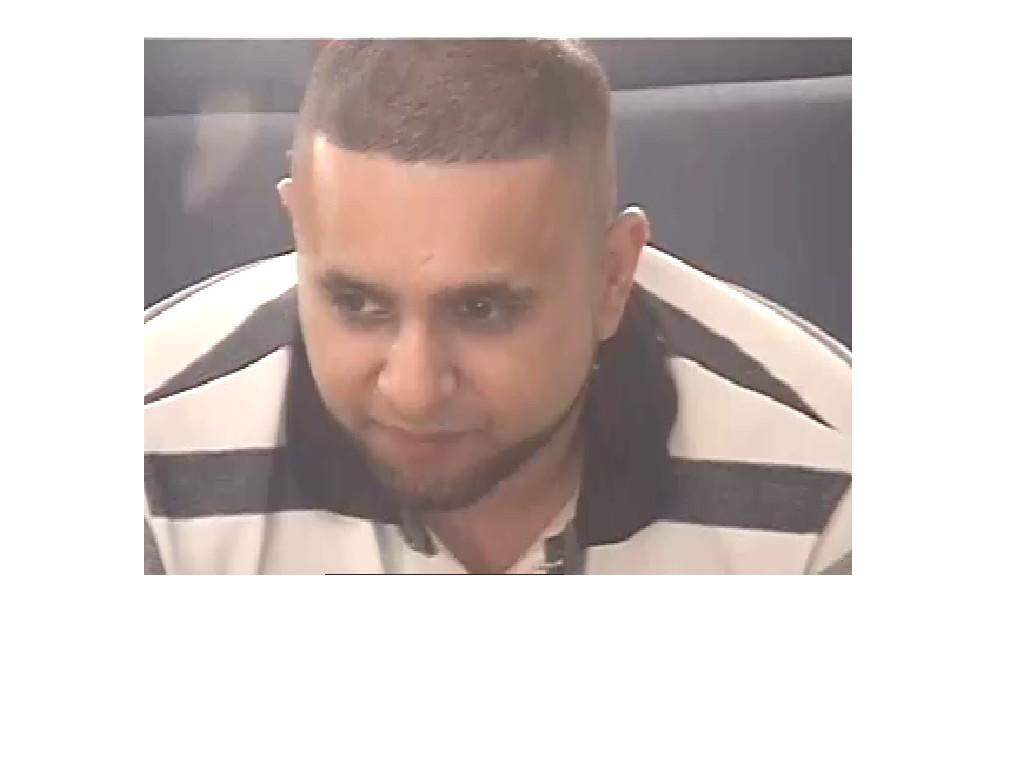What is present in the image? There is a person in the image. What is the person wearing? The person is wearing a white and black color shirt. What can be observed about the background of the image? The background of the image is black. How many chickens are present in the image? There are no chickens present in the image; it features a person wearing a white and black color shirt against a black background. What day of the week is depicted in the image? The image does not depict a specific day of the week; it only shows a person and the background color. 